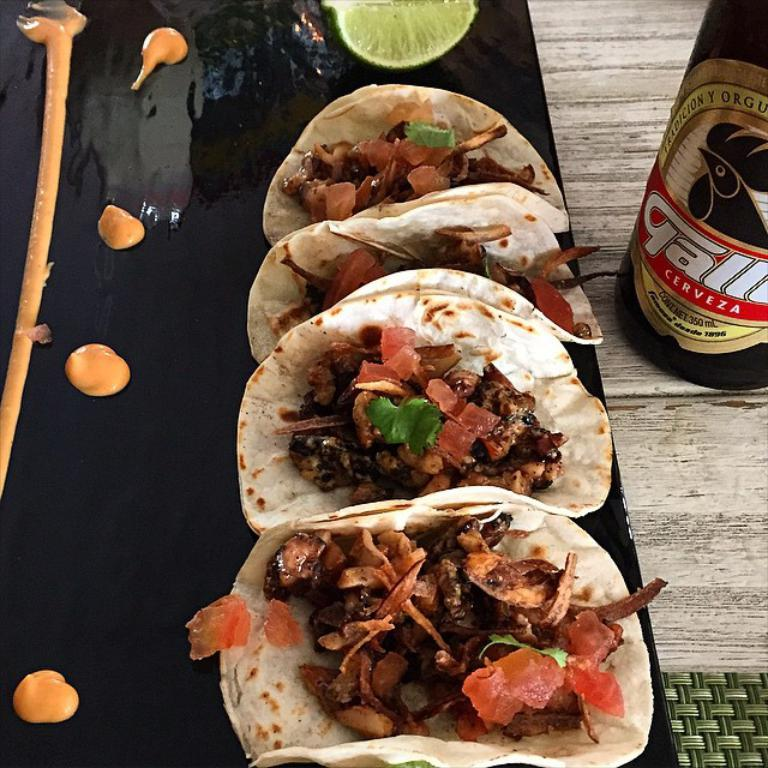What type of food item can be seen in the image? There is a food item in the image, which is a slice of lemon. What is the color of the plate that the cream is on? The plate is black in color. What beverage-related item is present in the image? There is a wine bottle in the image. How is the wine bottle being used or displayed in the image? The wine bottle looks like a table mat in the image. Where are the items in the image located? The items are on a table. What industry is represented by the light in the image? There is no light present in the image, so it cannot be associated with any industry. 